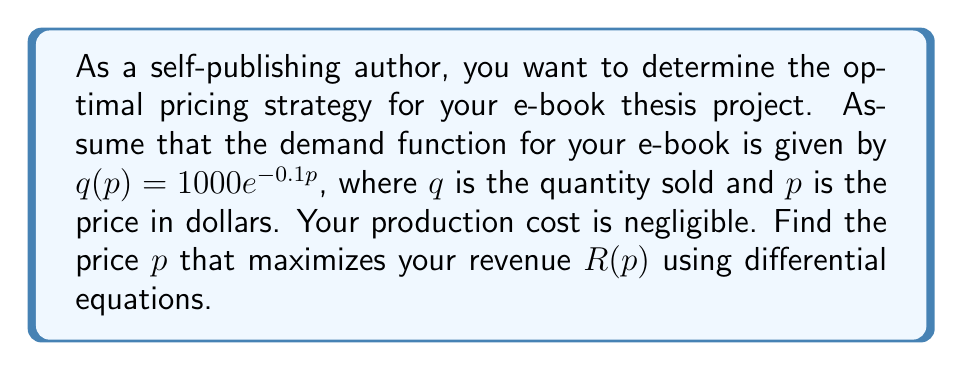Show me your answer to this math problem. To solve this problem, we'll follow these steps:

1) First, let's define the revenue function $R(p)$. Revenue is price multiplied by quantity:

   $R(p) = p \cdot q(p) = p \cdot 1000e^{-0.1p}$

2) To find the maximum revenue, we need to find where the derivative of $R(p)$ equals zero:

   $\frac{dR}{dp} = 0$

3) Let's calculate $\frac{dR}{dp}$ using the product rule:

   $\frac{dR}{dp} = 1000e^{-0.1p} + p \cdot (-100e^{-0.1p})$
   
   $\frac{dR}{dp} = 1000e^{-0.1p}(1 - 0.1p)$

4) Now, let's set this equal to zero and solve:

   $1000e^{-0.1p}(1 - 0.1p) = 0$

5) The exponential term is always positive, so we can divide both sides by $1000e^{-0.1p}$:

   $1 - 0.1p = 0$

6) Solving for p:

   $0.1p = 1$
   $p = 10$

7) To confirm this is a maximum (not a minimum), we could check the second derivative is negative at $p=10$, but we'll skip that step for brevity.

Therefore, the optimal price to maximize revenue is $10.
Answer: The optimal price to maximize revenue is $10. 